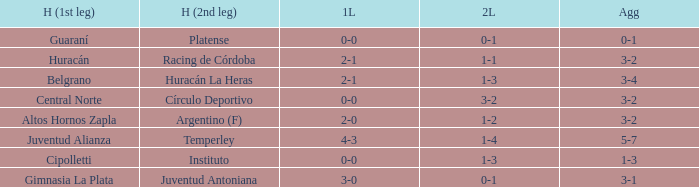Which team played the 2nd leg at home with a tie of 1-1 and scored 3-2 in aggregate? Racing de Córdoba. 